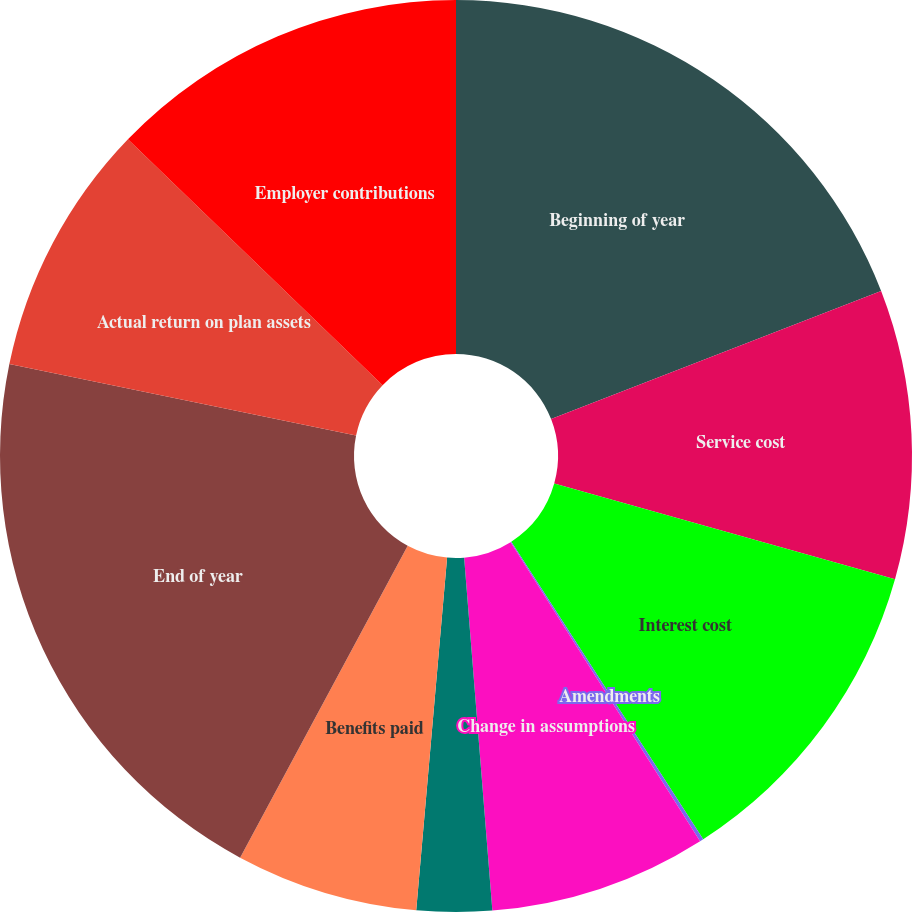Convert chart. <chart><loc_0><loc_0><loc_500><loc_500><pie_chart><fcel>Beginning of year<fcel>Service cost<fcel>Interest cost<fcel>Amendments<fcel>Change in assumptions<fcel>Actuarial loss<fcel>Benefits paid<fcel>End of year<fcel>Actual return on plan assets<fcel>Employer contributions<nl><fcel>19.11%<fcel>10.25%<fcel>11.52%<fcel>0.13%<fcel>7.72%<fcel>2.66%<fcel>6.46%<fcel>20.38%<fcel>8.99%<fcel>12.78%<nl></chart> 